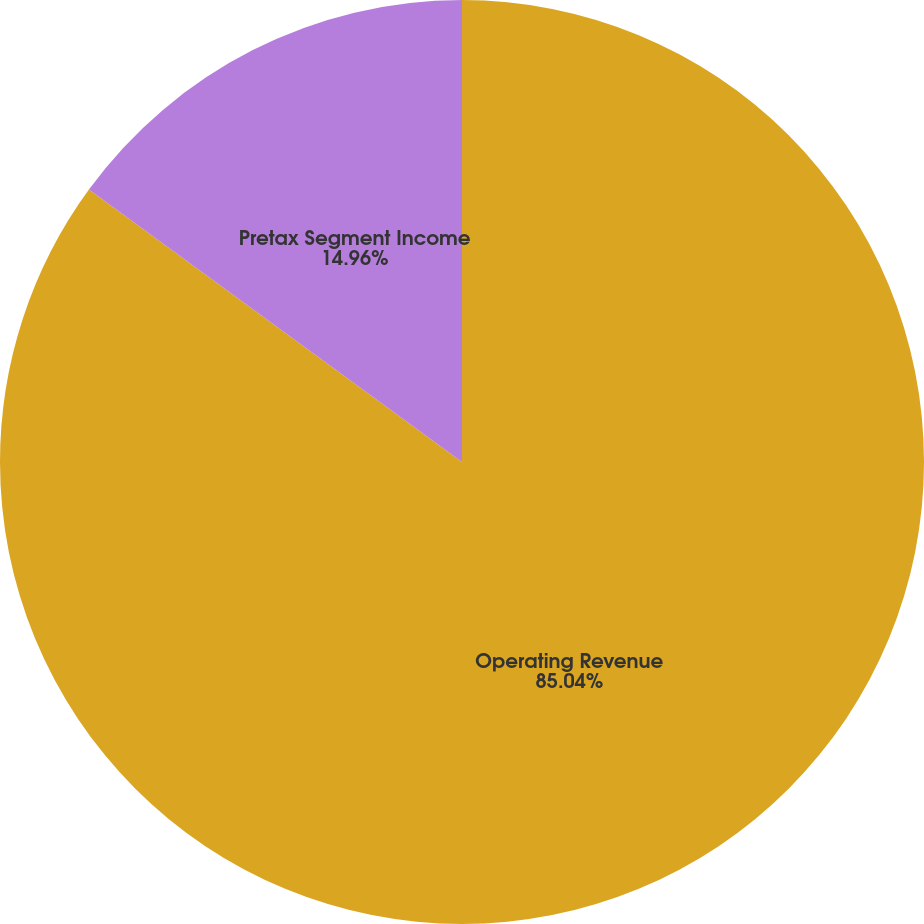Convert chart. <chart><loc_0><loc_0><loc_500><loc_500><pie_chart><fcel>Operating Revenue<fcel>Pretax Segment Income<nl><fcel>85.04%<fcel>14.96%<nl></chart> 